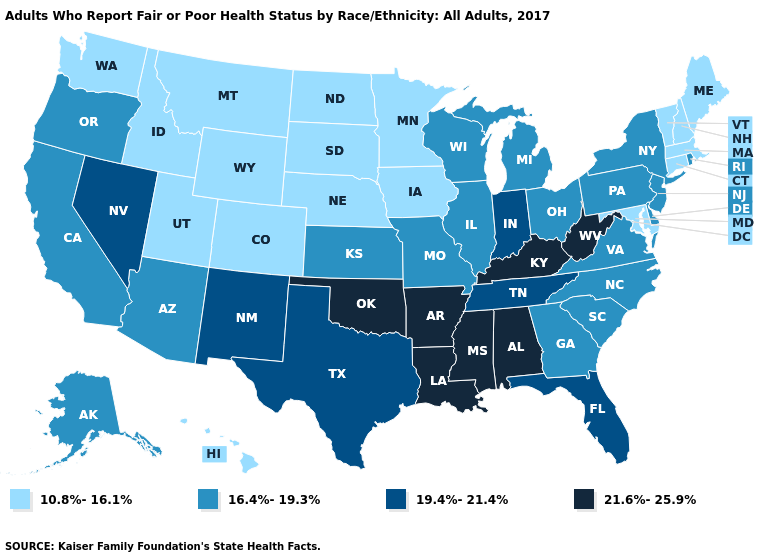How many symbols are there in the legend?
Be succinct. 4. What is the value of Massachusetts?
Concise answer only. 10.8%-16.1%. Name the states that have a value in the range 16.4%-19.3%?
Concise answer only. Alaska, Arizona, California, Delaware, Georgia, Illinois, Kansas, Michigan, Missouri, New Jersey, New York, North Carolina, Ohio, Oregon, Pennsylvania, Rhode Island, South Carolina, Virginia, Wisconsin. What is the value of Texas?
Quick response, please. 19.4%-21.4%. What is the lowest value in the South?
Concise answer only. 10.8%-16.1%. Among the states that border Washington , which have the highest value?
Be succinct. Oregon. Name the states that have a value in the range 21.6%-25.9%?
Concise answer only. Alabama, Arkansas, Kentucky, Louisiana, Mississippi, Oklahoma, West Virginia. Which states have the lowest value in the USA?
Short answer required. Colorado, Connecticut, Hawaii, Idaho, Iowa, Maine, Maryland, Massachusetts, Minnesota, Montana, Nebraska, New Hampshire, North Dakota, South Dakota, Utah, Vermont, Washington, Wyoming. Name the states that have a value in the range 16.4%-19.3%?
Quick response, please. Alaska, Arizona, California, Delaware, Georgia, Illinois, Kansas, Michigan, Missouri, New Jersey, New York, North Carolina, Ohio, Oregon, Pennsylvania, Rhode Island, South Carolina, Virginia, Wisconsin. Does South Dakota have the same value as Connecticut?
Quick response, please. Yes. Name the states that have a value in the range 10.8%-16.1%?
Concise answer only. Colorado, Connecticut, Hawaii, Idaho, Iowa, Maine, Maryland, Massachusetts, Minnesota, Montana, Nebraska, New Hampshire, North Dakota, South Dakota, Utah, Vermont, Washington, Wyoming. What is the value of Kentucky?
Give a very brief answer. 21.6%-25.9%. Among the states that border North Dakota , which have the lowest value?
Give a very brief answer. Minnesota, Montana, South Dakota. Name the states that have a value in the range 19.4%-21.4%?
Answer briefly. Florida, Indiana, Nevada, New Mexico, Tennessee, Texas. Name the states that have a value in the range 16.4%-19.3%?
Short answer required. Alaska, Arizona, California, Delaware, Georgia, Illinois, Kansas, Michigan, Missouri, New Jersey, New York, North Carolina, Ohio, Oregon, Pennsylvania, Rhode Island, South Carolina, Virginia, Wisconsin. 